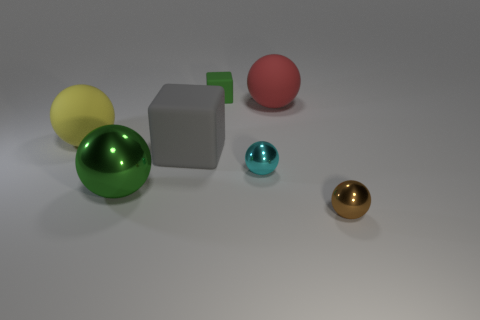Subtract all brown spheres. How many spheres are left? 4 Subtract all large yellow matte spheres. How many spheres are left? 4 Subtract all purple balls. Subtract all green cylinders. How many balls are left? 5 Add 1 big spheres. How many objects exist? 8 Subtract all balls. How many objects are left? 2 Subtract all cubes. Subtract all tiny cyan objects. How many objects are left? 4 Add 2 cyan metallic objects. How many cyan metallic objects are left? 3 Add 5 purple cylinders. How many purple cylinders exist? 5 Subtract 1 green blocks. How many objects are left? 6 